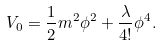<formula> <loc_0><loc_0><loc_500><loc_500>V _ { 0 } = \frac { 1 } { 2 } m ^ { 2 } \phi ^ { 2 } + \frac { \lambda } { 4 ! } \phi ^ { 4 } .</formula> 